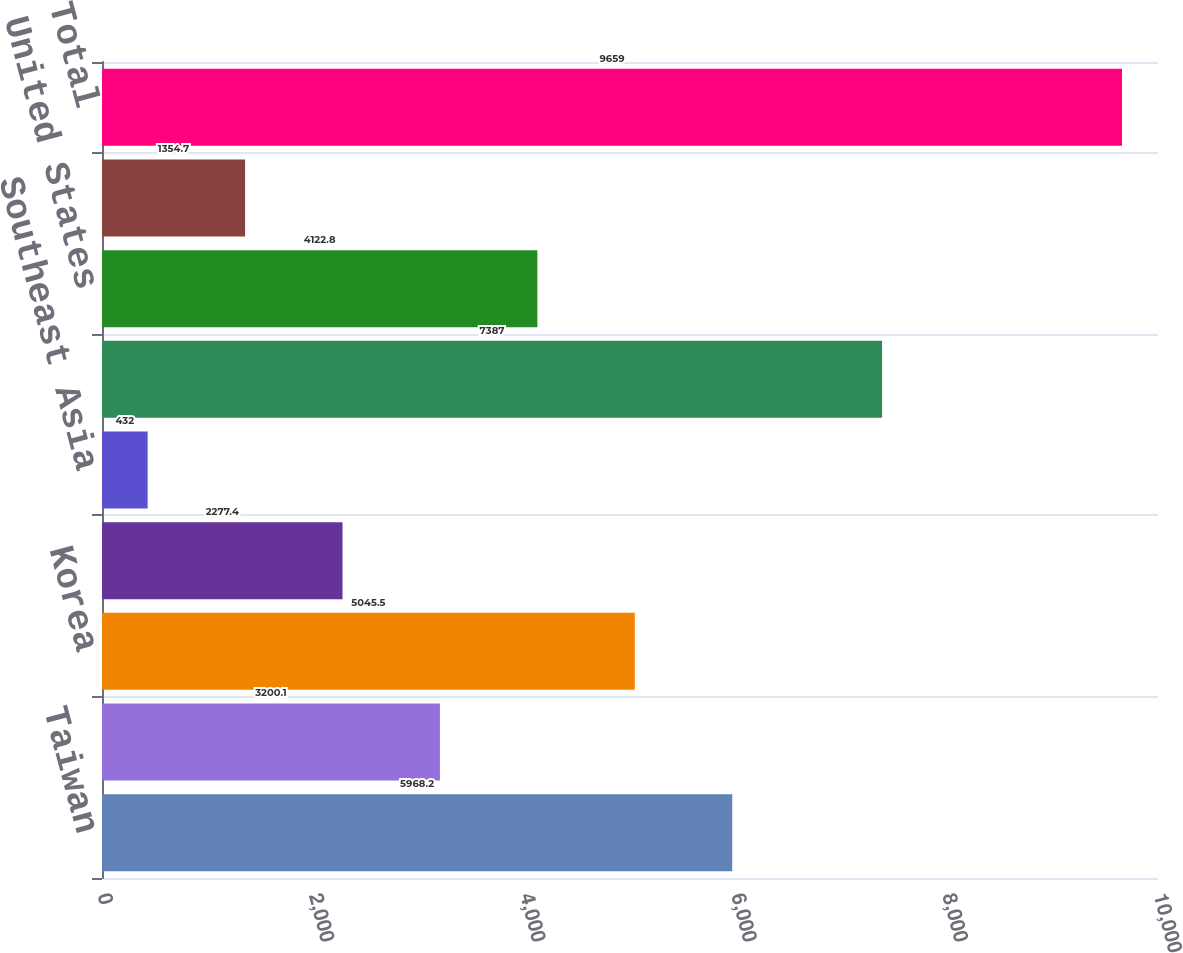<chart> <loc_0><loc_0><loc_500><loc_500><bar_chart><fcel>Taiwan<fcel>China<fcel>Korea<fcel>Japan<fcel>Southeast Asia<fcel>Asia Pacific<fcel>United States<fcel>Europe<fcel>Total<nl><fcel>5968.2<fcel>3200.1<fcel>5045.5<fcel>2277.4<fcel>432<fcel>7387<fcel>4122.8<fcel>1354.7<fcel>9659<nl></chart> 